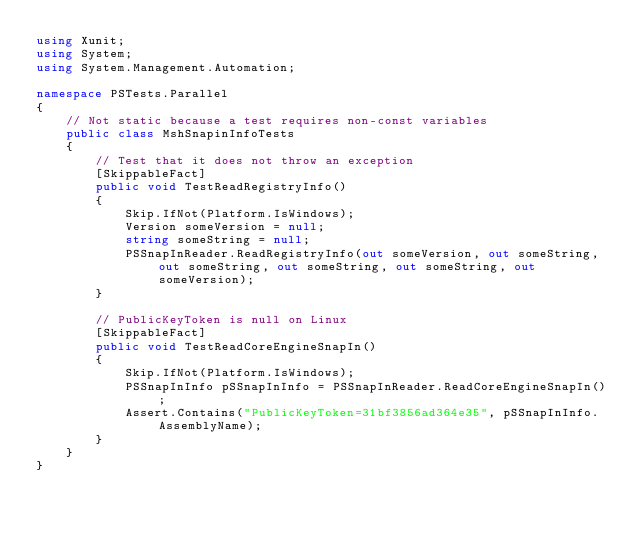Convert code to text. <code><loc_0><loc_0><loc_500><loc_500><_C#_>using Xunit;
using System;
using System.Management.Automation;

namespace PSTests.Parallel
{
    // Not static because a test requires non-const variables
    public class MshSnapinInfoTests
    {
        // Test that it does not throw an exception
        [SkippableFact]
        public void TestReadRegistryInfo()
        {
            Skip.IfNot(Platform.IsWindows);
            Version someVersion = null;
            string someString = null;
            PSSnapInReader.ReadRegistryInfo(out someVersion, out someString, out someString, out someString, out someString, out someVersion);
        }

        // PublicKeyToken is null on Linux
        [SkippableFact]
        public void TestReadCoreEngineSnapIn()
        {
            Skip.IfNot(Platform.IsWindows);
            PSSnapInInfo pSSnapInInfo = PSSnapInReader.ReadCoreEngineSnapIn();
            Assert.Contains("PublicKeyToken=31bf3856ad364e35", pSSnapInInfo.AssemblyName);
        }
    }
}
</code> 